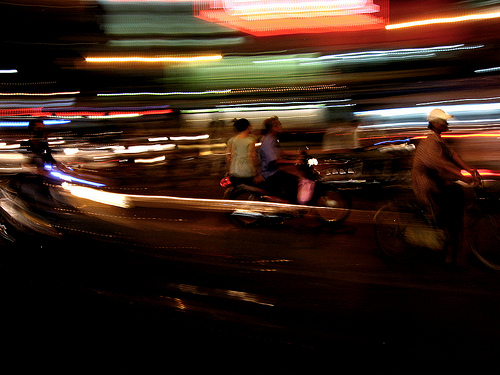<image>
Can you confirm if the blur is behind the tire? Yes. From this viewpoint, the blur is positioned behind the tire, with the tire partially or fully occluding the blur. 